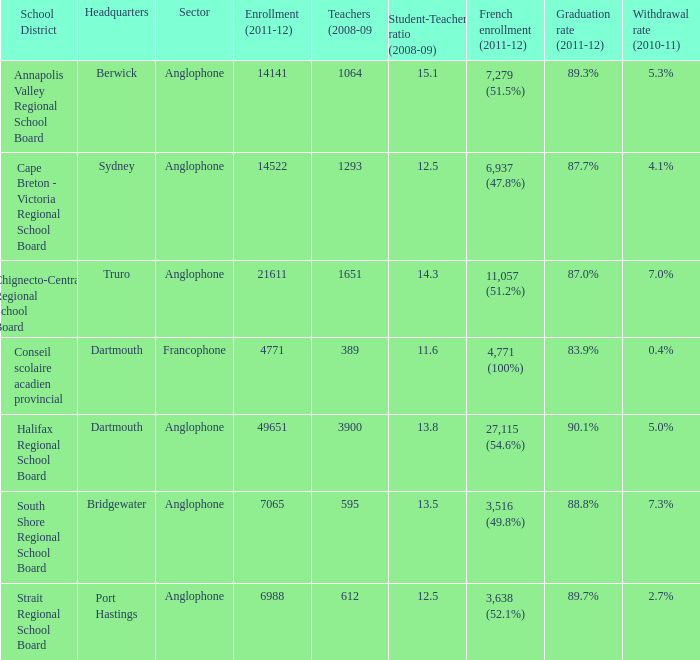Help me parse the entirety of this table. {'header': ['School District', 'Headquarters', 'Sector', 'Enrollment (2011-12)', 'Teachers (2008-09', 'Student-Teacher ratio (2008-09)', 'French enrollment (2011-12)', 'Graduation rate (2011-12)', 'Withdrawal rate (2010-11)'], 'rows': [['Annapolis Valley Regional School Board', 'Berwick', 'Anglophone', '14141', '1064', '15.1', '7,279 (51.5%)', '89.3%', '5.3%'], ['Cape Breton - Victoria Regional School Board', 'Sydney', 'Anglophone', '14522', '1293', '12.5', '6,937 (47.8%)', '87.7%', '4.1%'], ['Chignecto-Central Regional School Board', 'Truro', 'Anglophone', '21611', '1651', '14.3', '11,057 (51.2%)', '87.0%', '7.0%'], ['Conseil scolaire acadien provincial', 'Dartmouth', 'Francophone', '4771', '389', '11.6', '4,771 (100%)', '83.9%', '0.4%'], ['Halifax Regional School Board', 'Dartmouth', 'Anglophone', '49651', '3900', '13.8', '27,115 (54.6%)', '90.1%', '5.0%'], ['South Shore Regional School Board', 'Bridgewater', 'Anglophone', '7065', '595', '13.5', '3,516 (49.8%)', '88.8%', '7.3%'], ['Strait Regional School Board', 'Port Hastings', 'Anglophone', '6988', '612', '12.5', '3,638 (52.1%)', '89.7%', '2.7%']]} What is their withdrawal rate for the school district with headquarters located in Truro? 7.0%. 